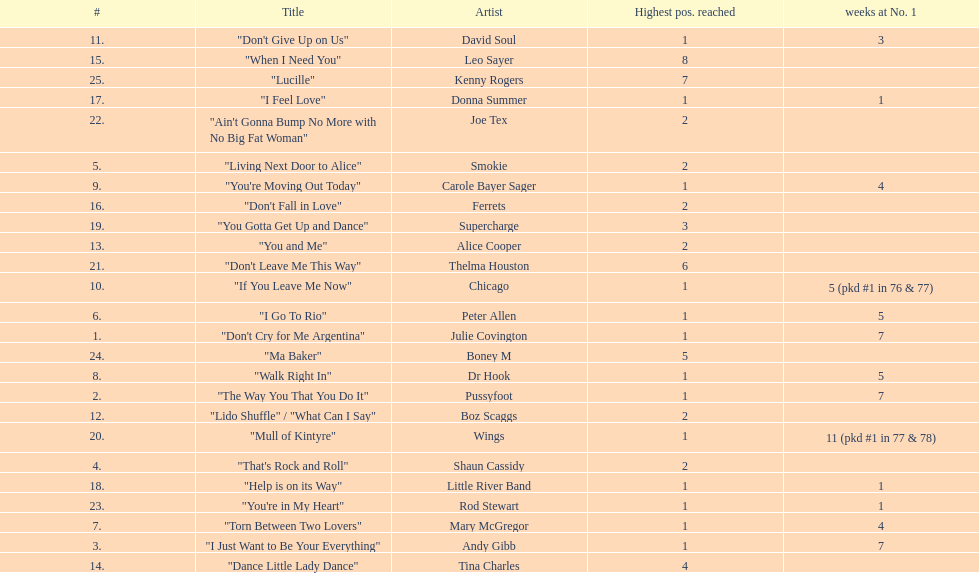How many weeks did julie covington's "don't cry for me argentina" spend at the top of australia's singles chart? 7. 